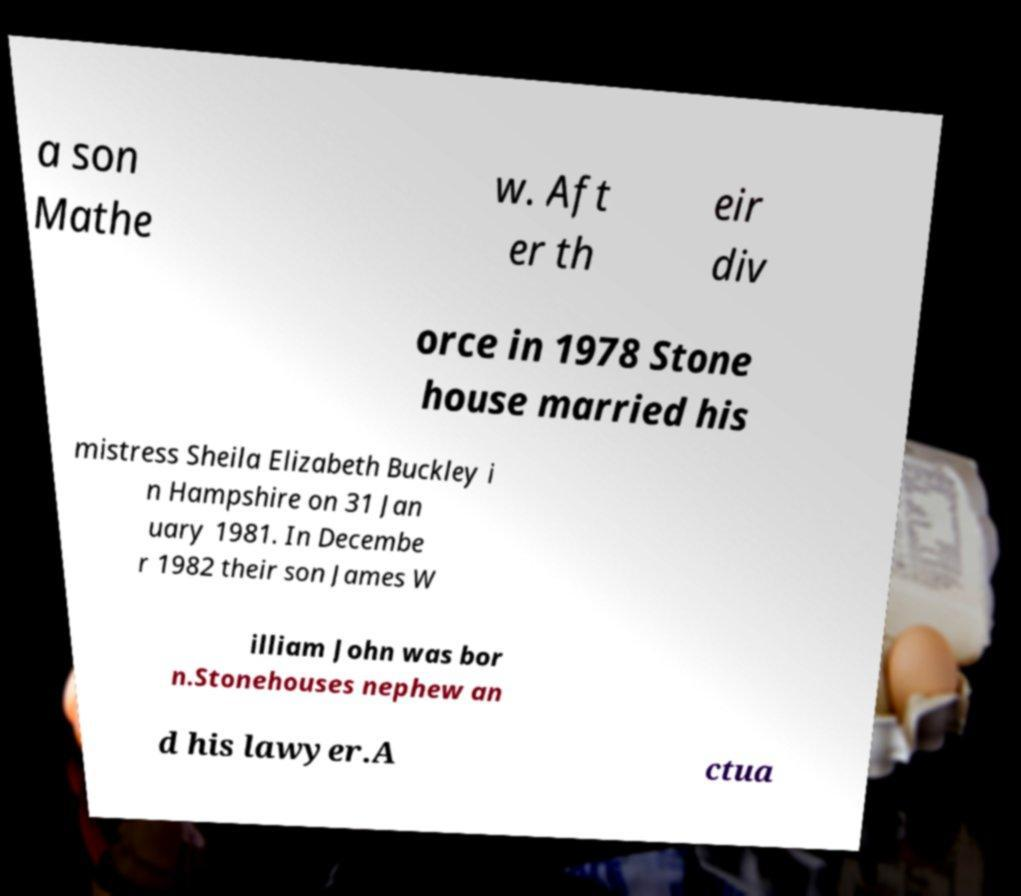Can you accurately transcribe the text from the provided image for me? a son Mathe w. Aft er th eir div orce in 1978 Stone house married his mistress Sheila Elizabeth Buckley i n Hampshire on 31 Jan uary 1981. In Decembe r 1982 their son James W illiam John was bor n.Stonehouses nephew an d his lawyer.A ctua 